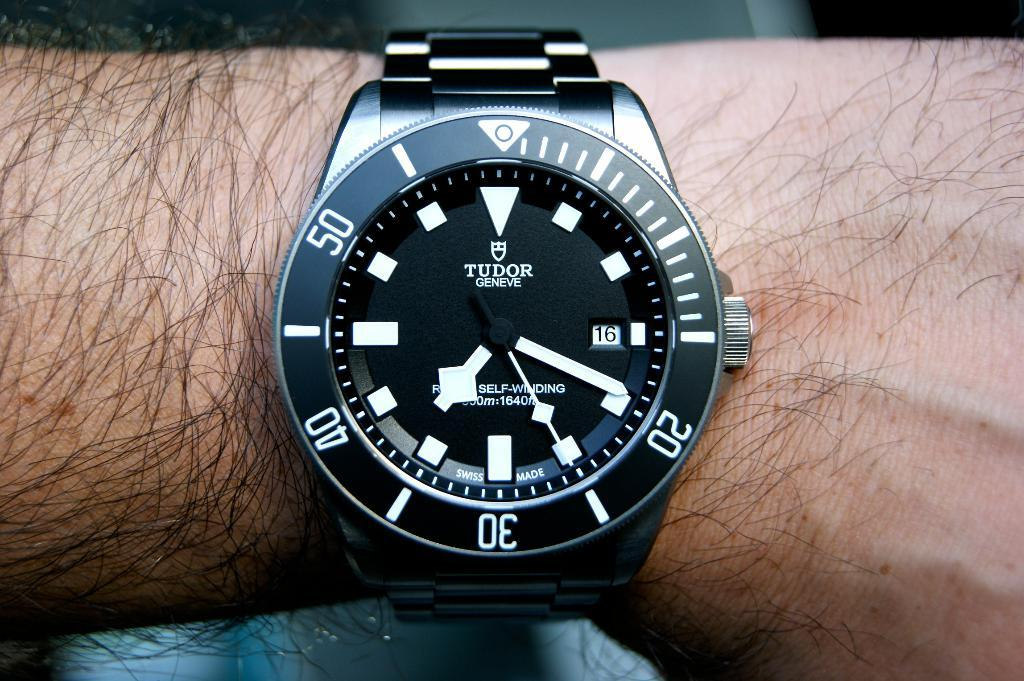<image>
Render a clear and concise summary of the photo. a tudor watch is on a persons arm 